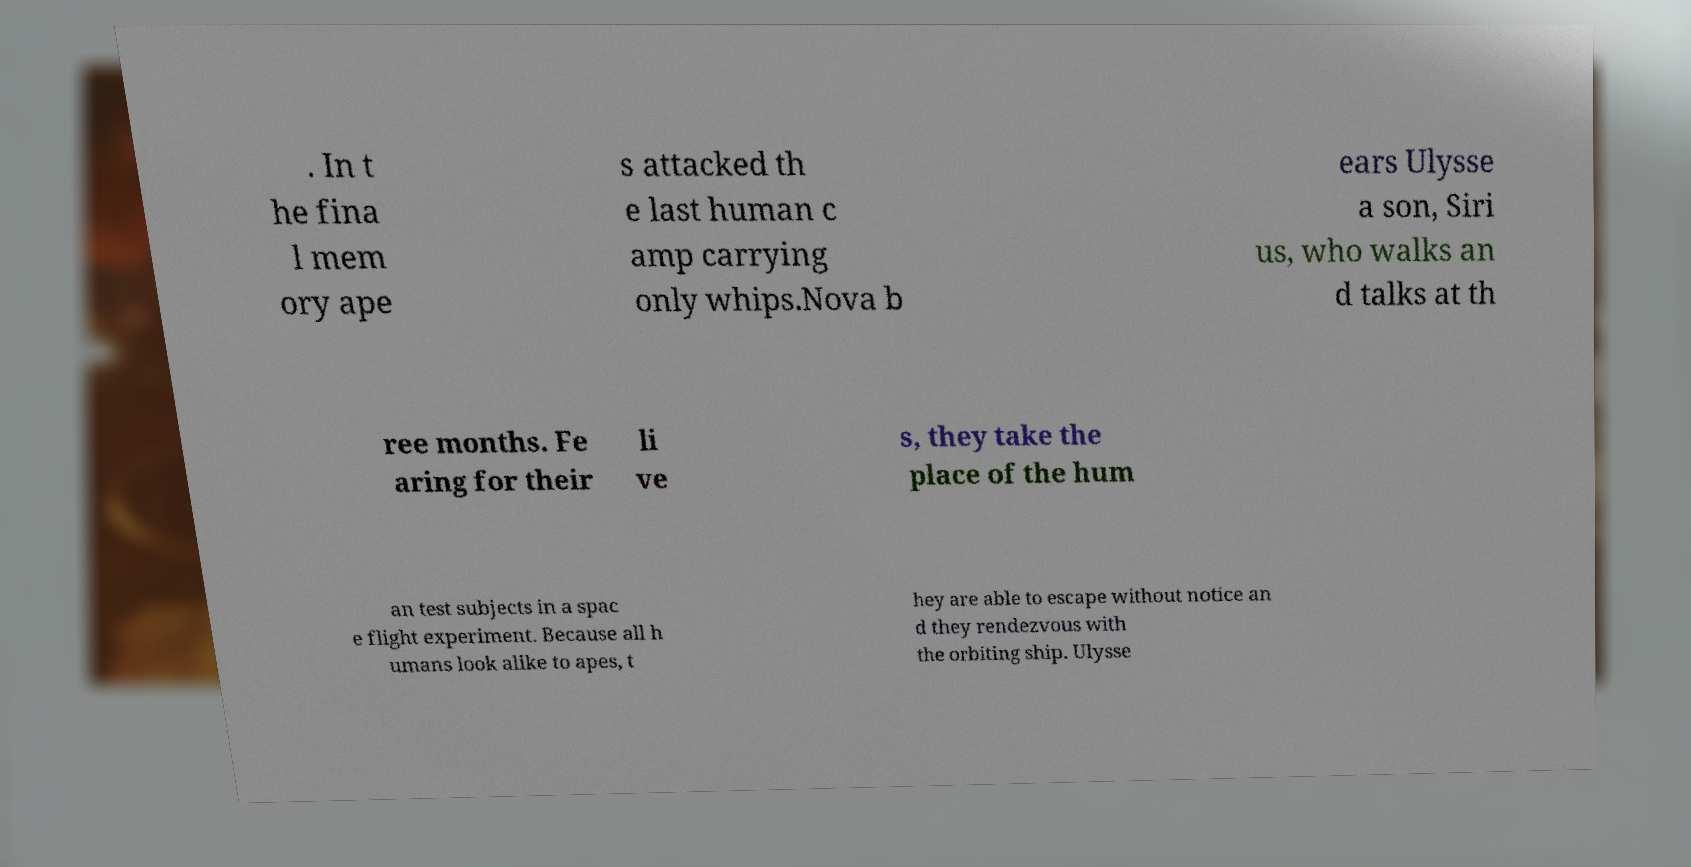I need the written content from this picture converted into text. Can you do that? . In t he fina l mem ory ape s attacked th e last human c amp carrying only whips.Nova b ears Ulysse a son, Siri us, who walks an d talks at th ree months. Fe aring for their li ve s, they take the place of the hum an test subjects in a spac e flight experiment. Because all h umans look alike to apes, t hey are able to escape without notice an d they rendezvous with the orbiting ship. Ulysse 